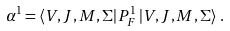Convert formula to latex. <formula><loc_0><loc_0><loc_500><loc_500>\alpha ^ { 1 } = \left < V , J , M , \Sigma \right | P ^ { 1 } _ { F } \left | V , J , M , \Sigma \right > \, .</formula> 